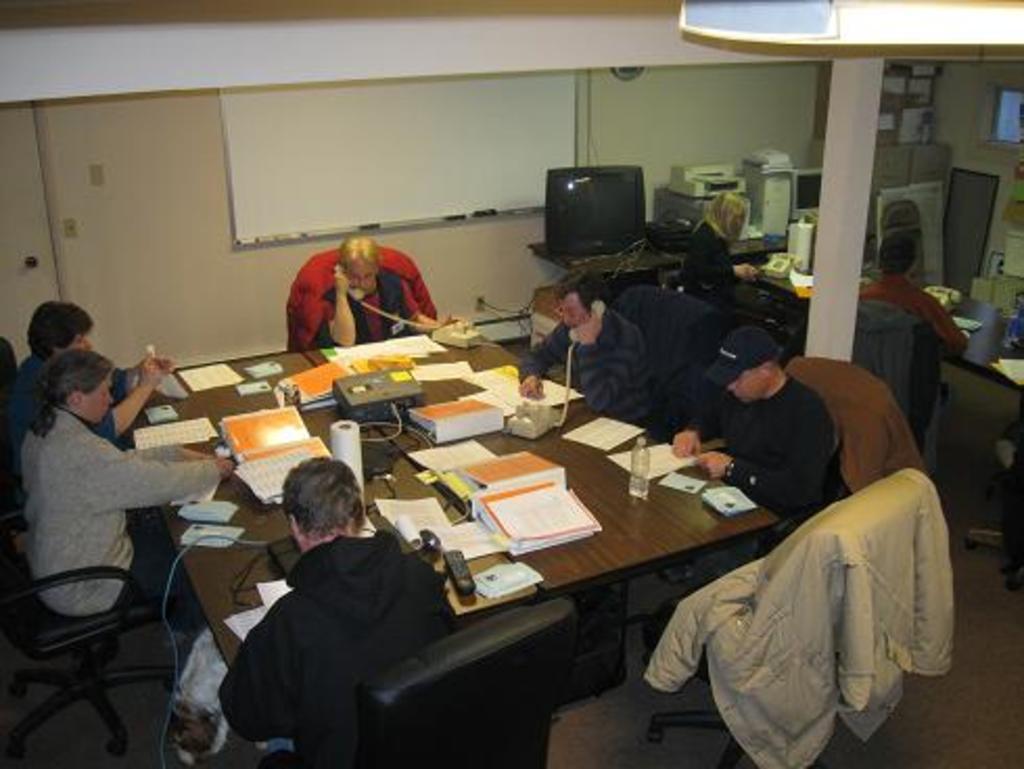How would you summarize this image in a sentence or two? On the background we can see a white board over a wall. we can see few devices on a table and also boxes. We can see few persons sitting on chairs in front of a table and on the table we can see telephone, device, files, papers, bottle and a remote. This is a jacket over a chair. This is a floor. 